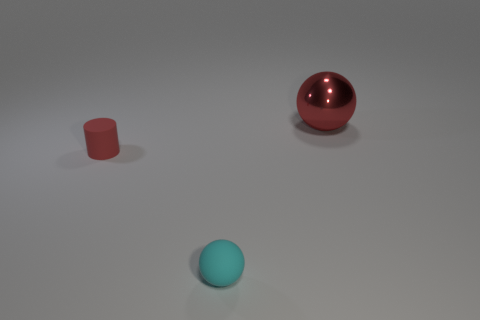Are there any other things that have the same size as the red sphere?
Give a very brief answer. No. Is there any other thing that has the same material as the cylinder?
Your response must be concise. Yes. What is the shape of the other tiny object that is the same color as the metal object?
Make the answer very short. Cylinder. There is a cylinder that is the same color as the large metal ball; what is its material?
Your response must be concise. Rubber. Do the red object that is in front of the red metallic thing and the thing to the right of the small cyan object have the same shape?
Make the answer very short. No. Are there any cyan spheres of the same size as the red matte thing?
Give a very brief answer. Yes. Are there an equal number of things on the right side of the cyan ball and large red metallic objects that are behind the big thing?
Provide a succinct answer. No. Do the red cylinder behind the small cyan object and the red thing behind the small red object have the same material?
Give a very brief answer. No. What material is the tiny cylinder?
Keep it short and to the point. Rubber. How many other objects are there of the same color as the rubber cylinder?
Provide a succinct answer. 1. 